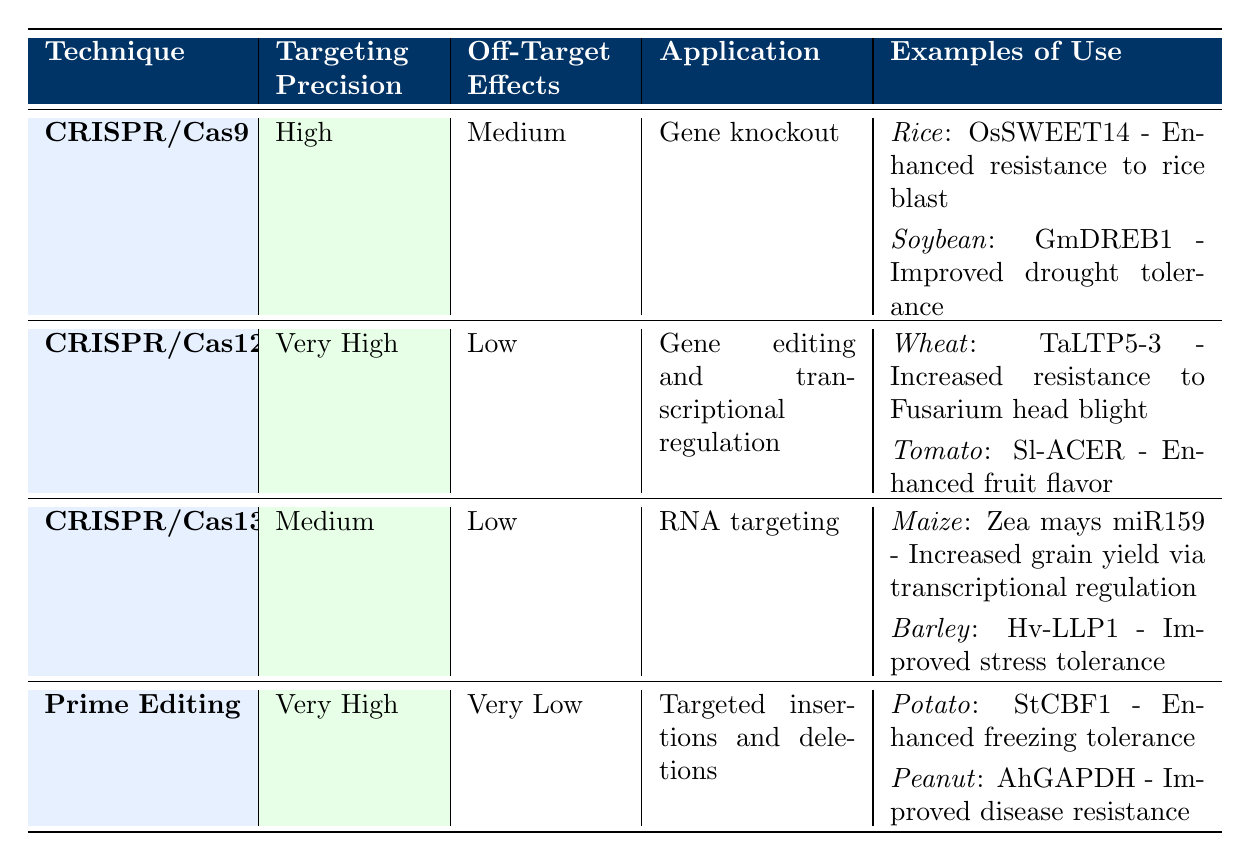What is the targeting precision of CRISPR/Cas12? The table states that the targeting precision for CRISPR/Cas12 is "Very High."
Answer: Very High Which technique has the lowest off-target effects? By looking at the off-target effects column in the table, Prime Editing is noted to have "Very Low" off-target effects, which is the least among the listed techniques.
Answer: Prime Editing How many techniques listed have a targeting precision of Medium? The table shows that CRISPR/Cas9 and CRISPR/Cas13 both have a targeting precision of "Medium." Therefore, there are 2 techniques with this precision.
Answer: 2 Is it true that CRISPR/Cas13 is used for gene knockout applications? The application for CRISPR/Cas13 is labeled as "RNA targeting," hence it does not cover gene knockout, making the statement false.
Answer: No Which crop is modified for enhanced resistance to Fusarium head blight? Referring to the examples of use, CRISPR/Cas12 has Wheat (TaLTP5-3) listed with the modification of "Increased resistance to Fusarium head blight."
Answer: Wheat What is the average targeting precision classification of all the techniques listed? The classifications are High, Very High, Medium, Very High. Converting these to numerical values (High=3, Very High=4, Medium=2), we get (3 + 4 + 2 + 4) = 13; dividing by the number of techniques (4) gives an average targeting precision of 3.25, which corresponds to a classification between High and Very High.
Answer: Between High and Very High Which technique is primarily used for gene editing and transcriptional regulation? CRISPR/Cas12 is specifically mentioned for "Gene editing and transcriptional regulation" in the application column, making it the correct answer.
Answer: CRISPR/Cas12 What modification does the StCBF1 gene confer in potato? According to the examples, the StCBF1 gene in potato leads to "Enhanced freezing tolerance."
Answer: Enhanced freezing tolerance 